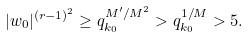<formula> <loc_0><loc_0><loc_500><loc_500>| w _ { 0 } | ^ { ( r - 1 ) ^ { 2 } } \geq q _ { k _ { 0 } } ^ { M ^ { \prime } / M ^ { 2 } } > q _ { k _ { 0 } } ^ { 1 / M } > 5 .</formula> 